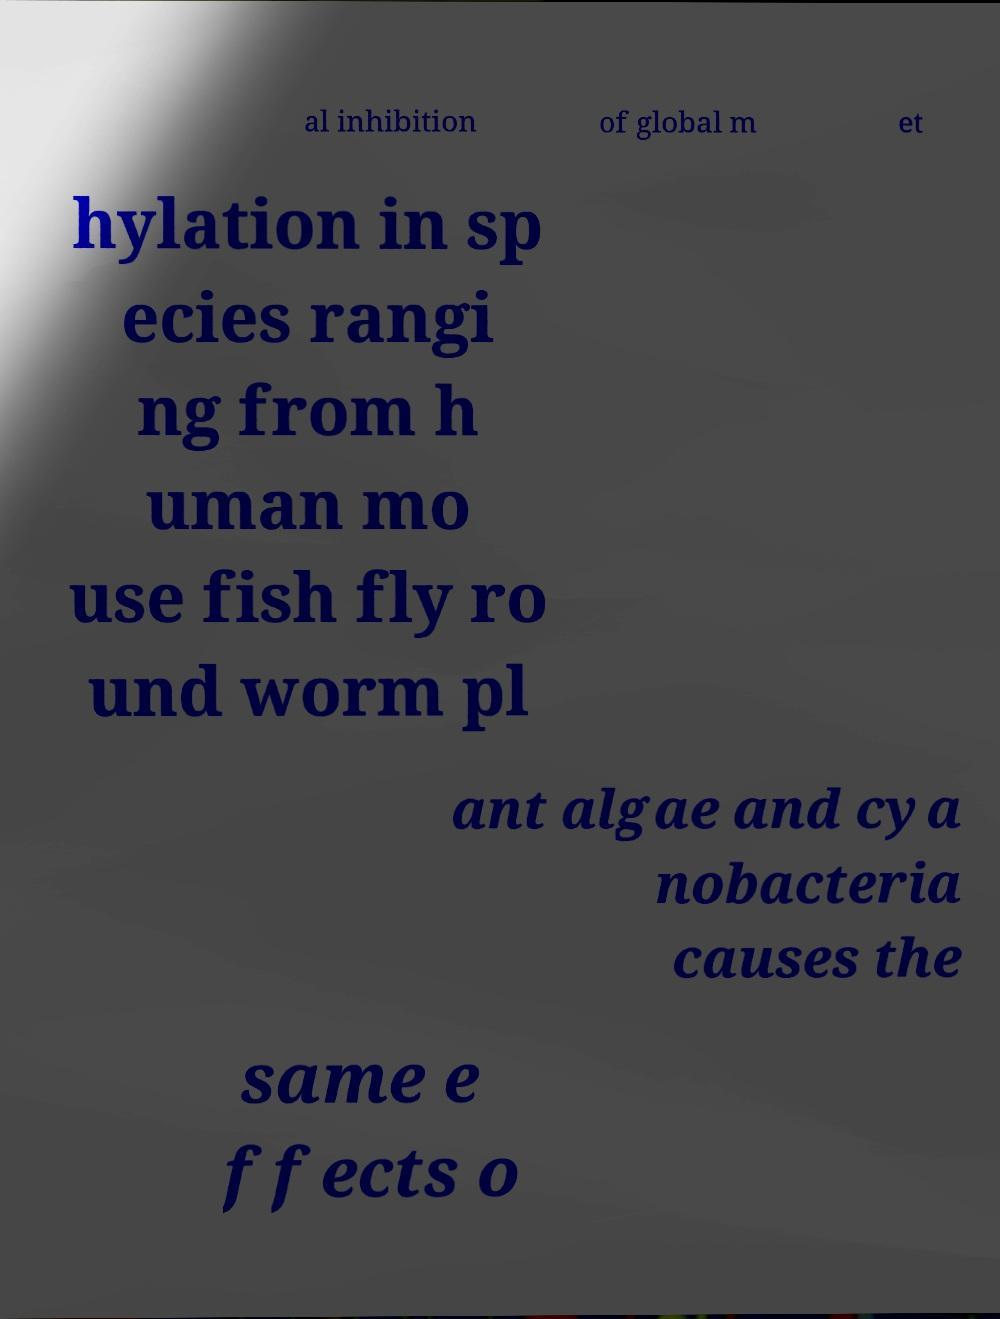Please identify and transcribe the text found in this image. al inhibition of global m et hylation in sp ecies rangi ng from h uman mo use fish fly ro und worm pl ant algae and cya nobacteria causes the same e ffects o 